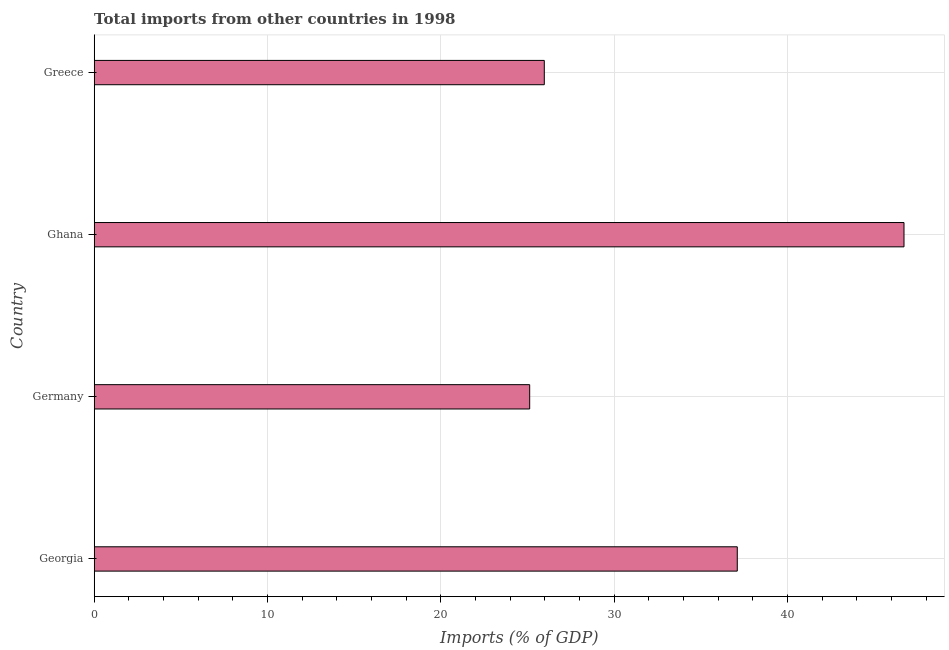Does the graph contain grids?
Provide a succinct answer. Yes. What is the title of the graph?
Offer a very short reply. Total imports from other countries in 1998. What is the label or title of the X-axis?
Keep it short and to the point. Imports (% of GDP). What is the label or title of the Y-axis?
Offer a very short reply. Country. What is the total imports in Ghana?
Provide a short and direct response. 46.73. Across all countries, what is the maximum total imports?
Offer a terse response. 46.73. Across all countries, what is the minimum total imports?
Offer a terse response. 25.13. In which country was the total imports maximum?
Your answer should be very brief. Ghana. In which country was the total imports minimum?
Offer a terse response. Germany. What is the sum of the total imports?
Provide a succinct answer. 134.94. What is the difference between the total imports in Germany and Ghana?
Ensure brevity in your answer.  -21.6. What is the average total imports per country?
Your response must be concise. 33.73. What is the median total imports?
Give a very brief answer. 31.54. In how many countries, is the total imports greater than 44 %?
Your answer should be very brief. 1. What is the ratio of the total imports in Ghana to that in Greece?
Your answer should be compact. 1.8. Is the total imports in Georgia less than that in Germany?
Keep it short and to the point. No. What is the difference between the highest and the second highest total imports?
Give a very brief answer. 9.62. What is the difference between the highest and the lowest total imports?
Give a very brief answer. 21.6. In how many countries, is the total imports greater than the average total imports taken over all countries?
Offer a terse response. 2. What is the difference between two consecutive major ticks on the X-axis?
Your answer should be compact. 10. What is the Imports (% of GDP) in Georgia?
Provide a succinct answer. 37.11. What is the Imports (% of GDP) of Germany?
Offer a terse response. 25.13. What is the Imports (% of GDP) of Ghana?
Offer a terse response. 46.73. What is the Imports (% of GDP) in Greece?
Ensure brevity in your answer.  25.97. What is the difference between the Imports (% of GDP) in Georgia and Germany?
Your answer should be very brief. 11.98. What is the difference between the Imports (% of GDP) in Georgia and Ghana?
Give a very brief answer. -9.62. What is the difference between the Imports (% of GDP) in Georgia and Greece?
Your response must be concise. 11.14. What is the difference between the Imports (% of GDP) in Germany and Ghana?
Your response must be concise. -21.6. What is the difference between the Imports (% of GDP) in Germany and Greece?
Offer a very short reply. -0.84. What is the difference between the Imports (% of GDP) in Ghana and Greece?
Provide a succinct answer. 20.76. What is the ratio of the Imports (% of GDP) in Georgia to that in Germany?
Keep it short and to the point. 1.48. What is the ratio of the Imports (% of GDP) in Georgia to that in Ghana?
Offer a terse response. 0.79. What is the ratio of the Imports (% of GDP) in Georgia to that in Greece?
Ensure brevity in your answer.  1.43. What is the ratio of the Imports (% of GDP) in Germany to that in Ghana?
Ensure brevity in your answer.  0.54. What is the ratio of the Imports (% of GDP) in Ghana to that in Greece?
Keep it short and to the point. 1.8. 